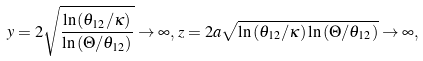Convert formula to latex. <formula><loc_0><loc_0><loc_500><loc_500>y = 2 \sqrt { { \frac { \ln { ( \theta _ { 1 2 } / \kappa ) } } { \ln { ( \Theta / \theta _ { 1 2 } ) } } } } \to \infty , \, z = 2 a \sqrt { \ln { ( \theta _ { 1 2 } / \kappa ) } \ln { ( \Theta / \theta _ { 1 2 } ) } } \to \infty ,</formula> 